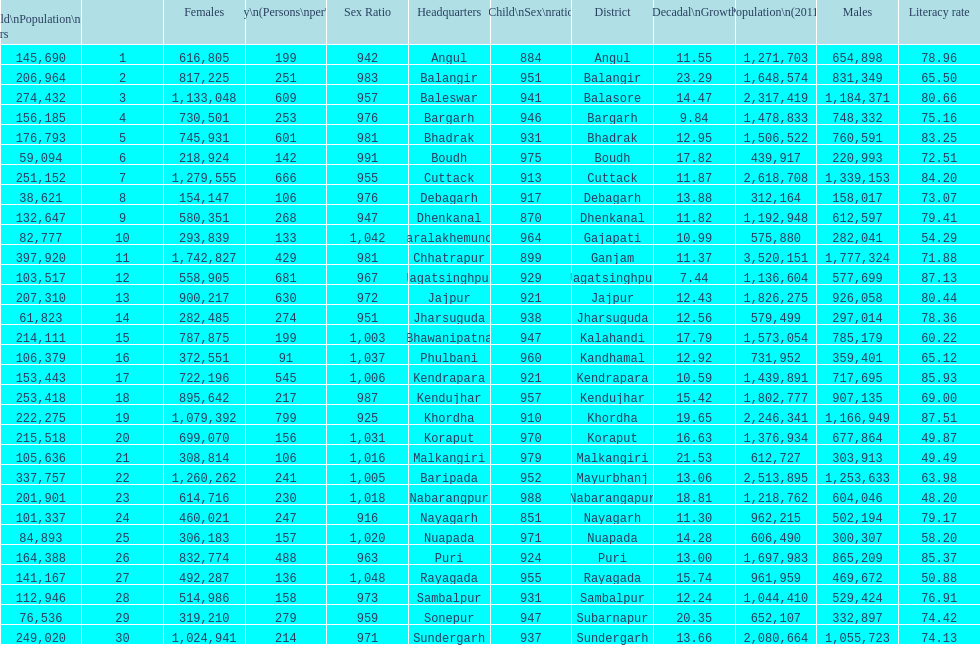Parse the full table. {'header': ['Child\\nPopulation\\n0–6 years', '', 'Females', 'Density\\n(Persons\\nper\\nkm2)', 'Sex Ratio', 'Headquarters', 'Child\\nSex\\nratio', 'District', 'Percentage\\nDecadal\\nGrowth\\n2001-2011', 'Population\\n(2011)', 'Males', 'Literacy rate'], 'rows': [['145,690', '1', '616,805', '199', '942', 'Angul', '884', 'Angul', '11.55', '1,271,703', '654,898', '78.96'], ['206,964', '2', '817,225', '251', '983', 'Balangir', '951', 'Balangir', '23.29', '1,648,574', '831,349', '65.50'], ['274,432', '3', '1,133,048', '609', '957', 'Baleswar', '941', 'Balasore', '14.47', '2,317,419', '1,184,371', '80.66'], ['156,185', '4', '730,501', '253', '976', 'Bargarh', '946', 'Bargarh', '9.84', '1,478,833', '748,332', '75.16'], ['176,793', '5', '745,931', '601', '981', 'Bhadrak', '931', 'Bhadrak', '12.95', '1,506,522', '760,591', '83.25'], ['59,094', '6', '218,924', '142', '991', 'Boudh', '975', 'Boudh', '17.82', '439,917', '220,993', '72.51'], ['251,152', '7', '1,279,555', '666', '955', 'Cuttack', '913', 'Cuttack', '11.87', '2,618,708', '1,339,153', '84.20'], ['38,621', '8', '154,147', '106', '976', 'Debagarh', '917', 'Debagarh', '13.88', '312,164', '158,017', '73.07'], ['132,647', '9', '580,351', '268', '947', 'Dhenkanal', '870', 'Dhenkanal', '11.82', '1,192,948', '612,597', '79.41'], ['82,777', '10', '293,839', '133', '1,042', 'Paralakhemundi', '964', 'Gajapati', '10.99', '575,880', '282,041', '54.29'], ['397,920', '11', '1,742,827', '429', '981', 'Chhatrapur', '899', 'Ganjam', '11.37', '3,520,151', '1,777,324', '71.88'], ['103,517', '12', '558,905', '681', '967', 'Jagatsinghpur', '929', 'Jagatsinghpur', '7.44', '1,136,604', '577,699', '87.13'], ['207,310', '13', '900,217', '630', '972', 'Jajpur', '921', 'Jajpur', '12.43', '1,826,275', '926,058', '80.44'], ['61,823', '14', '282,485', '274', '951', 'Jharsuguda', '938', 'Jharsuguda', '12.56', '579,499', '297,014', '78.36'], ['214,111', '15', '787,875', '199', '1,003', 'Bhawanipatna', '947', 'Kalahandi', '17.79', '1,573,054', '785,179', '60.22'], ['106,379', '16', '372,551', '91', '1,037', 'Phulbani', '960', 'Kandhamal', '12.92', '731,952', '359,401', '65.12'], ['153,443', '17', '722,196', '545', '1,006', 'Kendrapara', '921', 'Kendrapara', '10.59', '1,439,891', '717,695', '85.93'], ['253,418', '18', '895,642', '217', '987', 'Kendujhar', '957', 'Kendujhar', '15.42', '1,802,777', '907,135', '69.00'], ['222,275', '19', '1,079,392', '799', '925', 'Khordha', '910', 'Khordha', '19.65', '2,246,341', '1,166,949', '87.51'], ['215,518', '20', '699,070', '156', '1,031', 'Koraput', '970', 'Koraput', '16.63', '1,376,934', '677,864', '49.87'], ['105,636', '21', '308,814', '106', '1,016', 'Malkangiri', '979', 'Malkangiri', '21.53', '612,727', '303,913', '49.49'], ['337,757', '22', '1,260,262', '241', '1,005', 'Baripada', '952', 'Mayurbhanj', '13.06', '2,513,895', '1,253,633', '63.98'], ['201,901', '23', '614,716', '230', '1,018', 'Nabarangpur', '988', 'Nabarangapur', '18.81', '1,218,762', '604,046', '48.20'], ['101,337', '24', '460,021', '247', '916', 'Nayagarh', '851', 'Nayagarh', '11.30', '962,215', '502,194', '79.17'], ['84,893', '25', '306,183', '157', '1,020', 'Nuapada', '971', 'Nuapada', '14.28', '606,490', '300,307', '58.20'], ['164,388', '26', '832,774', '488', '963', 'Puri', '924', 'Puri', '13.00', '1,697,983', '865,209', '85.37'], ['141,167', '27', '492,287', '136', '1,048', 'Rayagada', '955', 'Rayagada', '15.74', '961,959', '469,672', '50.88'], ['112,946', '28', '514,986', '158', '973', 'Sambalpur', '931', 'Sambalpur', '12.24', '1,044,410', '529,424', '76.91'], ['76,536', '29', '319,210', '279', '959', 'Sonepur', '947', 'Subarnapur', '20.35', '652,107', '332,897', '74.42'], ['249,020', '30', '1,024,941', '214', '971', 'Sundergarh', '937', 'Sundergarh', '13.66', '2,080,664', '1,055,723', '74.13']]} What is the difference in child population between koraput and puri? 51,130. 